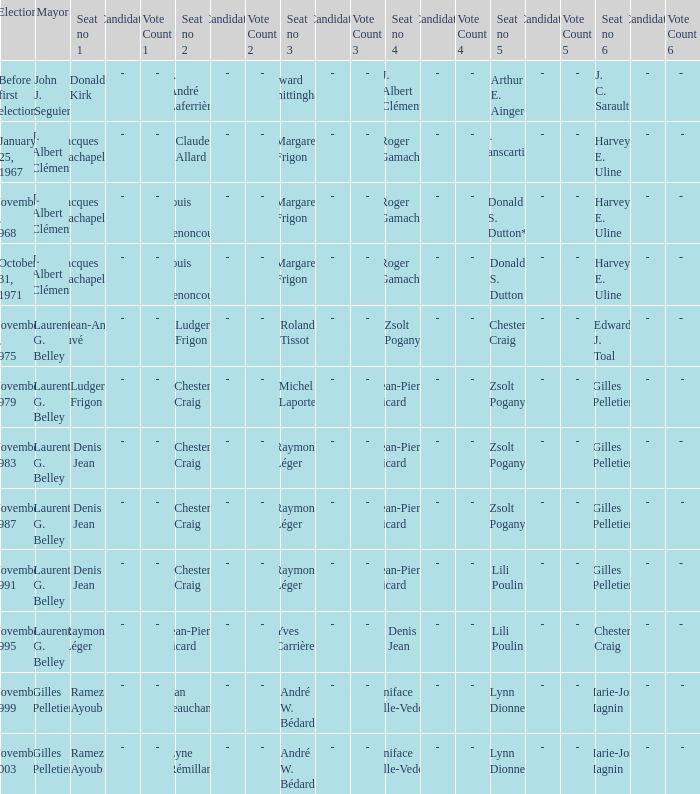Who held seat no 1 while john j. seguier served as mayor? Donald Kirk. 